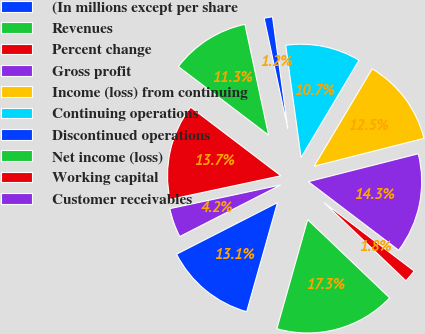Convert chart. <chart><loc_0><loc_0><loc_500><loc_500><pie_chart><fcel>(In millions except per share<fcel>Revenues<fcel>Percent change<fcel>Gross profit<fcel>Income (loss) from continuing<fcel>Continuing operations<fcel>Discontinued operations<fcel>Net income (loss)<fcel>Working capital<fcel>Customer receivables<nl><fcel>13.1%<fcel>17.26%<fcel>1.79%<fcel>14.29%<fcel>12.5%<fcel>10.71%<fcel>1.19%<fcel>11.31%<fcel>13.69%<fcel>4.17%<nl></chart> 